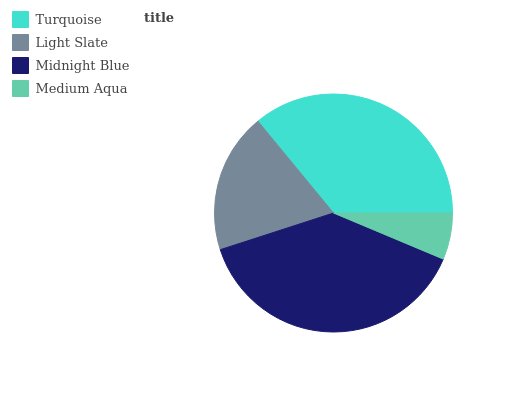Is Medium Aqua the minimum?
Answer yes or no. Yes. Is Midnight Blue the maximum?
Answer yes or no. Yes. Is Light Slate the minimum?
Answer yes or no. No. Is Light Slate the maximum?
Answer yes or no. No. Is Turquoise greater than Light Slate?
Answer yes or no. Yes. Is Light Slate less than Turquoise?
Answer yes or no. Yes. Is Light Slate greater than Turquoise?
Answer yes or no. No. Is Turquoise less than Light Slate?
Answer yes or no. No. Is Turquoise the high median?
Answer yes or no. Yes. Is Light Slate the low median?
Answer yes or no. Yes. Is Medium Aqua the high median?
Answer yes or no. No. Is Turquoise the low median?
Answer yes or no. No. 